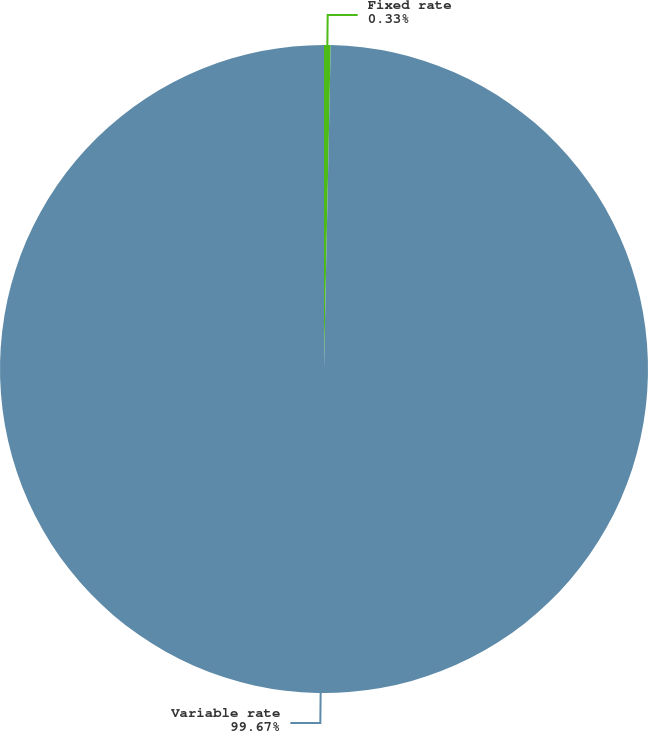<chart> <loc_0><loc_0><loc_500><loc_500><pie_chart><fcel>Fixed rate<fcel>Variable rate<nl><fcel>0.33%<fcel>99.67%<nl></chart> 